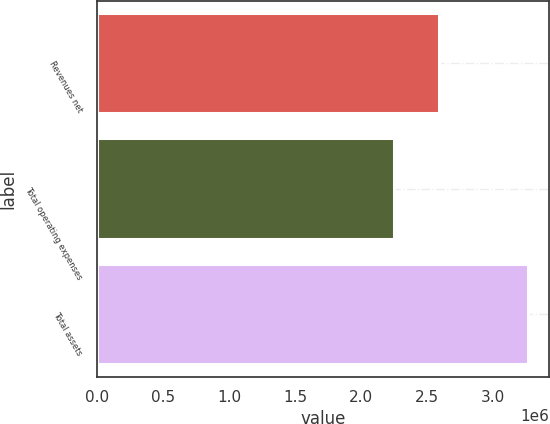<chart> <loc_0><loc_0><loc_500><loc_500><bar_chart><fcel>Revenues net<fcel>Total operating expenses<fcel>Total assets<nl><fcel>2.59333e+06<fcel>2.24666e+06<fcel>3.26467e+06<nl></chart> 